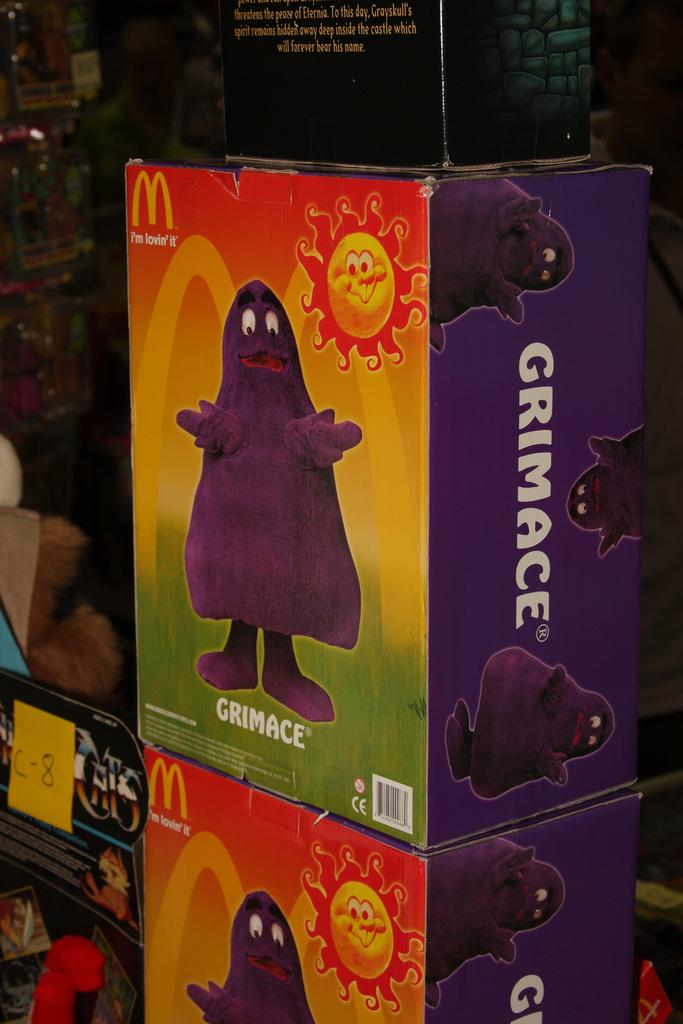<image>
Provide a brief description of the given image. a box of a mcdonalds character named 'grimace' 